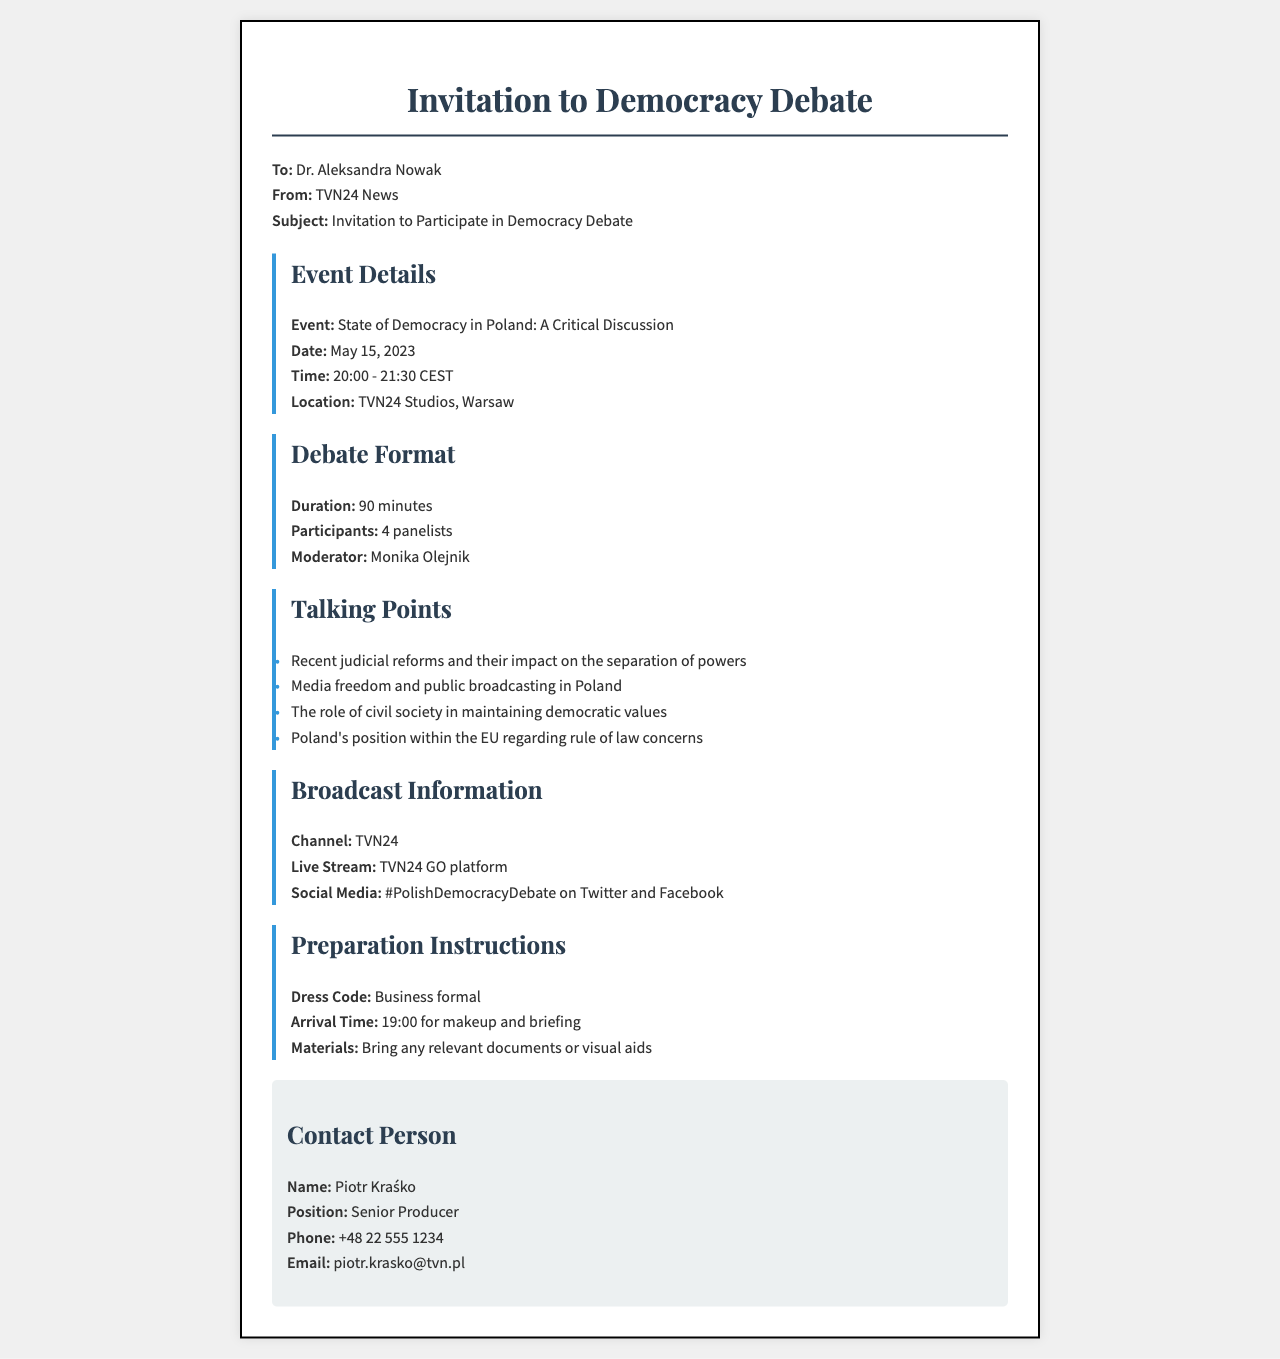what is the date of the debate? The date of the debate is mentioned clearly in the document as May 15, 2023.
Answer: May 15, 2023 who is the moderator of the debate? The document specifies that Monika Olejnik will be the moderator for the debate.
Answer: Monika Olejnik how long is the debate scheduled to last? The duration of the debate is stated in the document as 90 minutes.
Answer: 90 minutes what is the dress code for participants? The dress code is indicated in the preparation instructions section as business formal.
Answer: Business formal what topics will be discussed during the debate? The document lists several talking points including judicial reforms and media freedom, indicating what will be discussed.
Answer: Judicial reforms, media freedom, civil society's role, EU's position on rule of law who should be contacted for more information? The document provides a contact person, Piotr Kraśko, for further inquiries regarding the event.
Answer: Piotr Kraśko what is the live stream platform for the debate? The document states that the live stream will be available on the TVN24 GO platform.
Answer: TVN24 GO what time should participants arrive? The preparation instructions mention that participants should arrive by 19:00 for makeup and briefing.
Answer: 19:00 